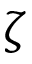Convert formula to latex. <formula><loc_0><loc_0><loc_500><loc_500>\zeta</formula> 